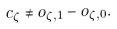<formula> <loc_0><loc_0><loc_500><loc_500>c _ { \zeta } \neq o _ { \zeta , 1 } - o _ { \zeta , 0 } .</formula> 